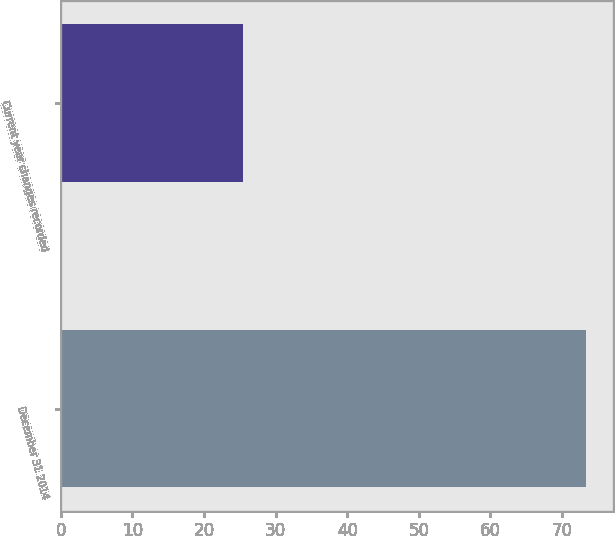Convert chart to OTSL. <chart><loc_0><loc_0><loc_500><loc_500><bar_chart><fcel>December 31 2014<fcel>Current year changes recorded<nl><fcel>73.4<fcel>25.4<nl></chart> 